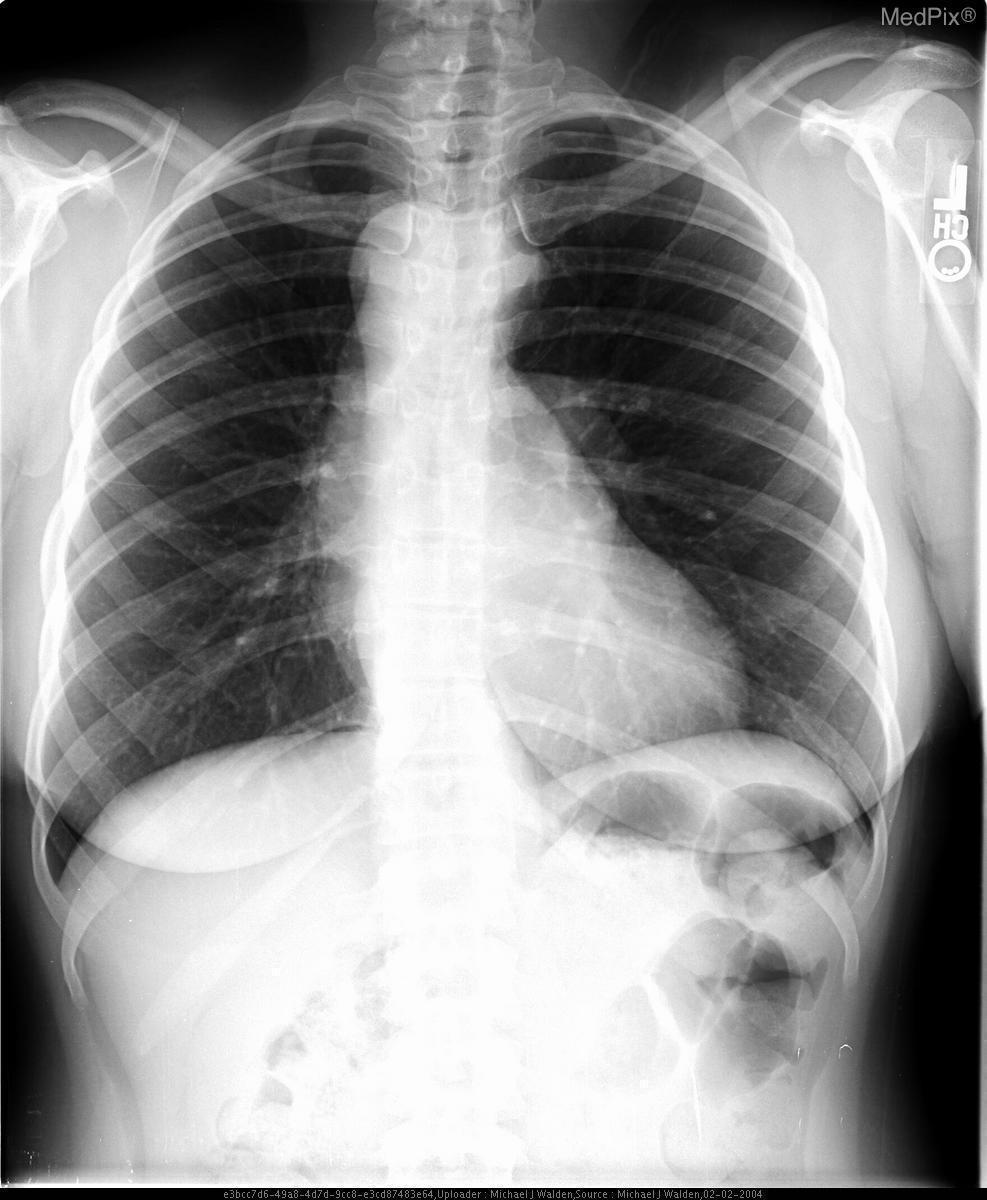What does the abnormal contour of the left hilum suggest in terms of pathology?
Keep it brief. Double arch. Is the patient's heart enlarged?
Give a very brief answer. No. Does the heart look enlarged?
Concise answer only. No. What is the abnormality seen above the heart on the patient's right side?
Be succinct. Right sided aortic arch. What is the bump seen above the heart on the patient's right side?
Write a very short answer. Right sided aortic arch. Imaging modality used to take this image?
Give a very brief answer. Pa xray. What imaging modality is used to acquire this picture?
Answer briefly. Pa xray. 